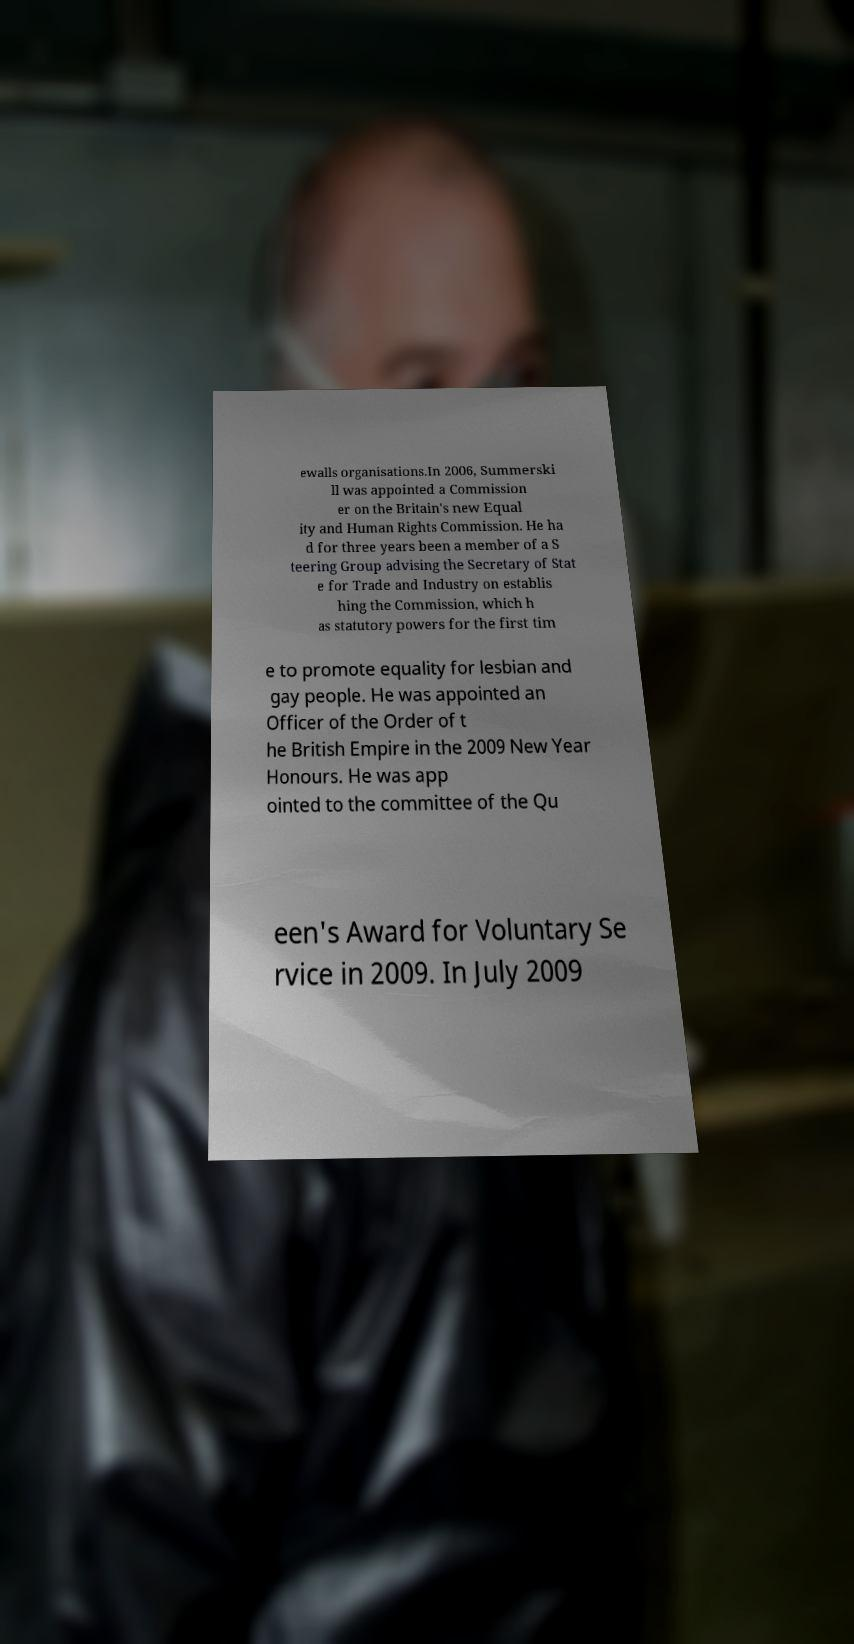Can you accurately transcribe the text from the provided image for me? ewalls organisations.In 2006, Summerski ll was appointed a Commission er on the Britain's new Equal ity and Human Rights Commission. He ha d for three years been a member of a S teering Group advising the Secretary of Stat e for Trade and Industry on establis hing the Commission, which h as statutory powers for the first tim e to promote equality for lesbian and gay people. He was appointed an Officer of the Order of t he British Empire in the 2009 New Year Honours. He was app ointed to the committee of the Qu een's Award for Voluntary Se rvice in 2009. In July 2009 